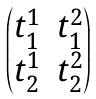Convert formula to latex. <formula><loc_0><loc_0><loc_500><loc_500>\begin{pmatrix} t _ { 1 } ^ { 1 } & t _ { 1 } ^ { 2 } \\ t _ { 2 } ^ { 1 } & t _ { 2 } ^ { 2 } \end{pmatrix}</formula> 